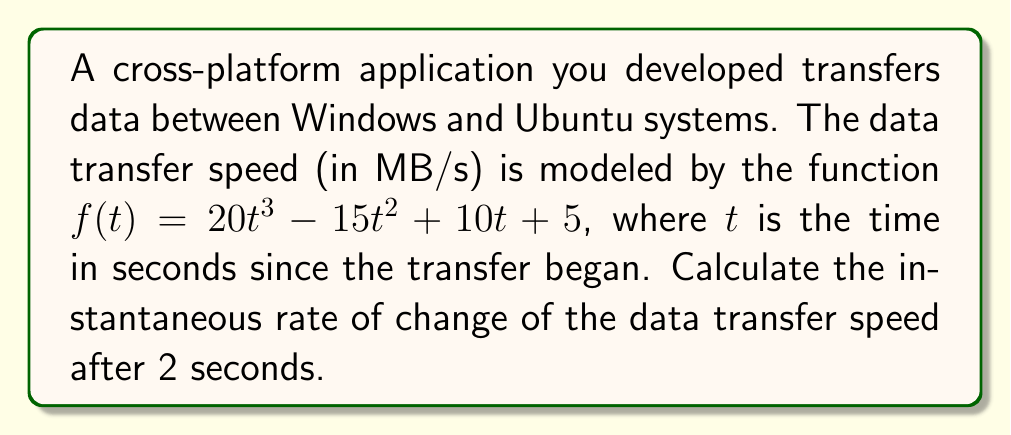Show me your answer to this math problem. To find the instantaneous rate of change of the data transfer speed after 2 seconds, we need to calculate the derivative of the given function and evaluate it at $t = 2$.

Step 1: Find the derivative of $f(t)$.
$$f'(t) = \frac{d}{dt}(20t^3 - 15t^2 + 10t + 5)$$
$$f'(t) = 60t^2 - 30t + 10$$

Step 2: Evaluate the derivative at $t = 2$.
$$f'(2) = 60(2)^2 - 30(2) + 10$$
$$f'(2) = 60(4) - 60 + 10$$
$$f'(2) = 240 - 60 + 10$$
$$f'(2) = 190$$

The instantaneous rate of change of the data transfer speed after 2 seconds is 190 MB/s².

This means that at exactly 2 seconds into the data transfer, the speed is increasing at a rate of 190 MB/s per second.
Answer: 190 MB/s² 